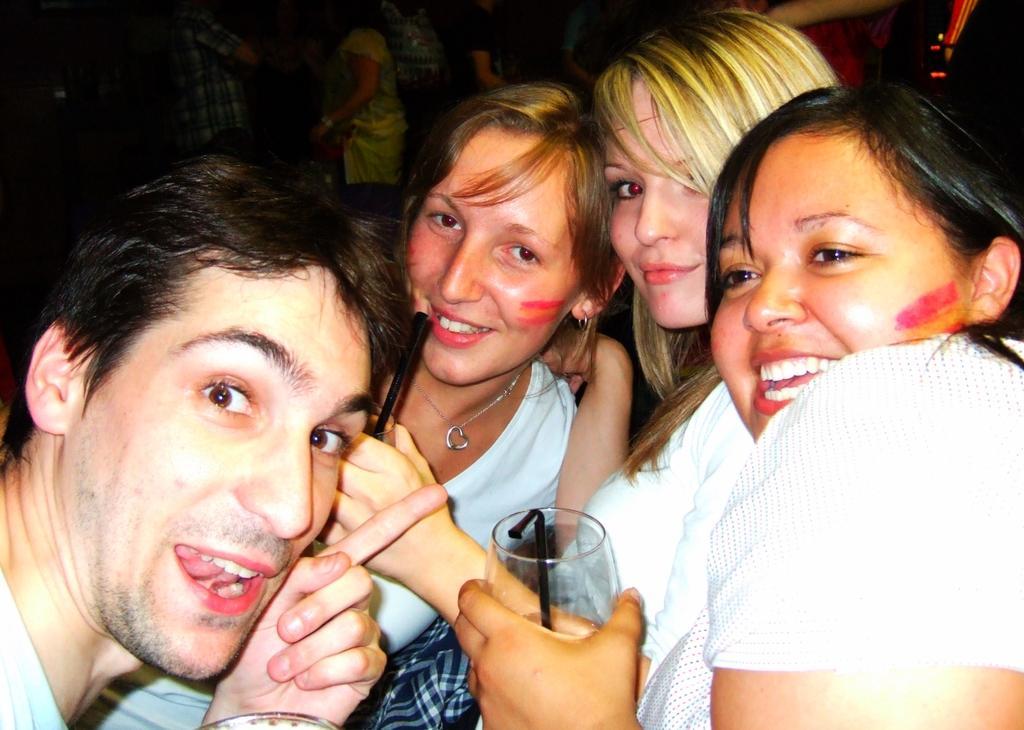Could you give a brief overview of what you see in this image? To the left bottom of the image there is a man with white t-shirt. Beside him there is a lady with white t-shirt and a chain around her neck. Beside her there is a lady with white t-shirt is smiling. To the right side there is a lady with white t-shirt is laughing and holding the glass with a black straw in it. To the top of the image behind these people there are few people standing. 